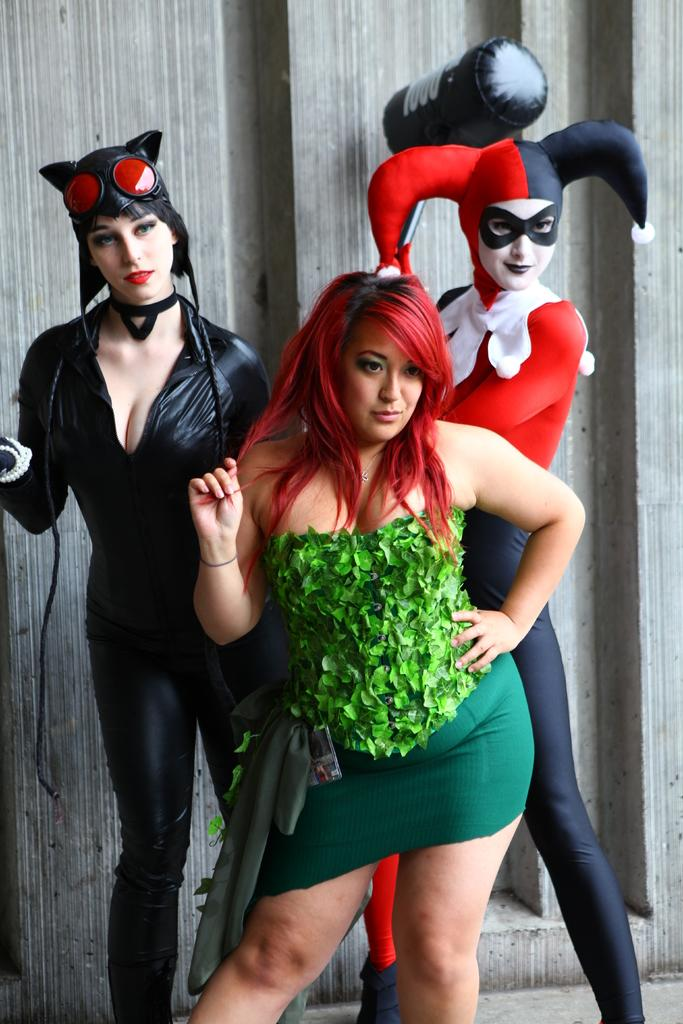How many women are in the image? There are three women in the image. What can be observed about the women's attire? The women are wearing different costumes. What are the women doing in the image? The women are looking at someone. What type of iron can be seen in the image? There is no iron present in the image. What kind of destruction is happening in the image? There is no destruction present in the image. 